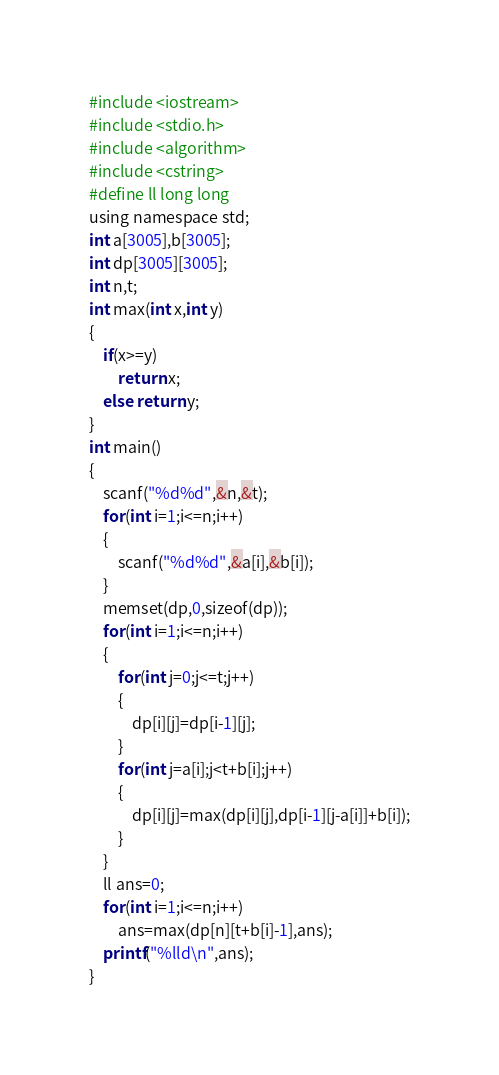<code> <loc_0><loc_0><loc_500><loc_500><_Awk_>#include <iostream>
#include <stdio.h>
#include <algorithm>
#include <cstring>
#define ll long long
using namespace std;
int a[3005],b[3005];
int dp[3005][3005];
int n,t;
int max(int x,int y)
{
    if(x>=y)
        return x;
    else return y;
}
int main()
{
    scanf("%d%d",&n,&t);
    for(int i=1;i<=n;i++)
    {
        scanf("%d%d",&a[i],&b[i]);
    }
    memset(dp,0,sizeof(dp));
    for(int i=1;i<=n;i++)
    {
        for(int j=0;j<=t;j++)
        {
            dp[i][j]=dp[i-1][j];
        }
        for(int j=a[i];j<t+b[i];j++)
        {
            dp[i][j]=max(dp[i][j],dp[i-1][j-a[i]]+b[i]);
        }
    }
    ll ans=0;
    for(int i=1;i<=n;i++)
        ans=max(dp[n][t+b[i]-1],ans);
    printf("%lld\n",ans);
}
</code> 